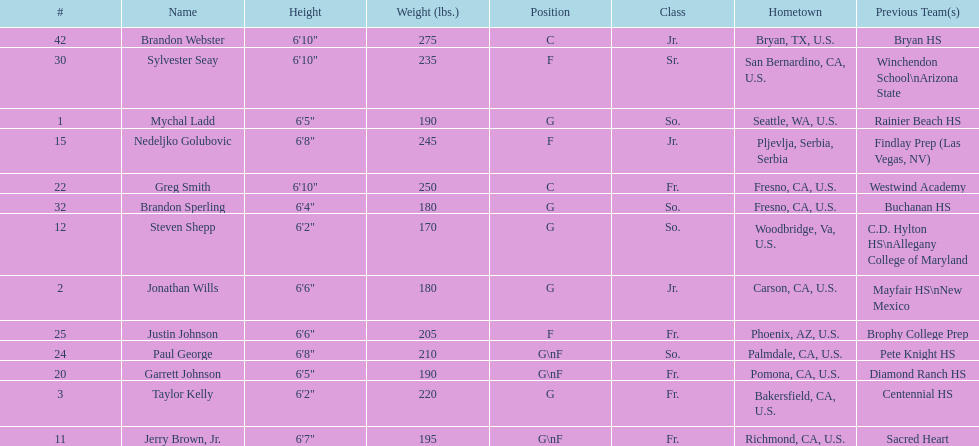Which player is taller, paul george or greg smith? Greg Smith. 